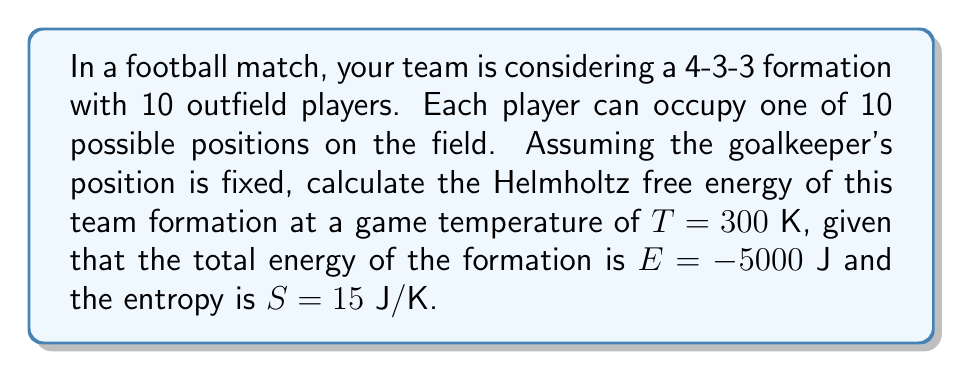Can you solve this math problem? To solve this problem, we'll use the fundamental equation for Helmholtz free energy in statistical mechanics:

$$F = E - TS$$

Where:
$F$ = Helmholtz free energy
$E$ = Total energy of the system
$T$ = Temperature
$S$ = Entropy

Given:
$E = -5000$ J
$T = 300$ K
$S = 15$ J/K

Step 1: Substitute the given values into the equation:

$$F = -5000 - (300 \times 15)$$

Step 2: Multiply the temperature and entropy:

$$F = -5000 - 4500$$

Step 3: Perform the final subtraction:

$$F = -9500\text{ J}$$

The negative free energy indicates that this formation is spontaneous and favorable under the given conditions, which aligns with the strategic choice of a commonly used formation in football.
Answer: $-9500\text{ J}$ 